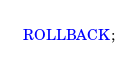<code> <loc_0><loc_0><loc_500><loc_500><_SQL_>ROLLBACK;
</code> 